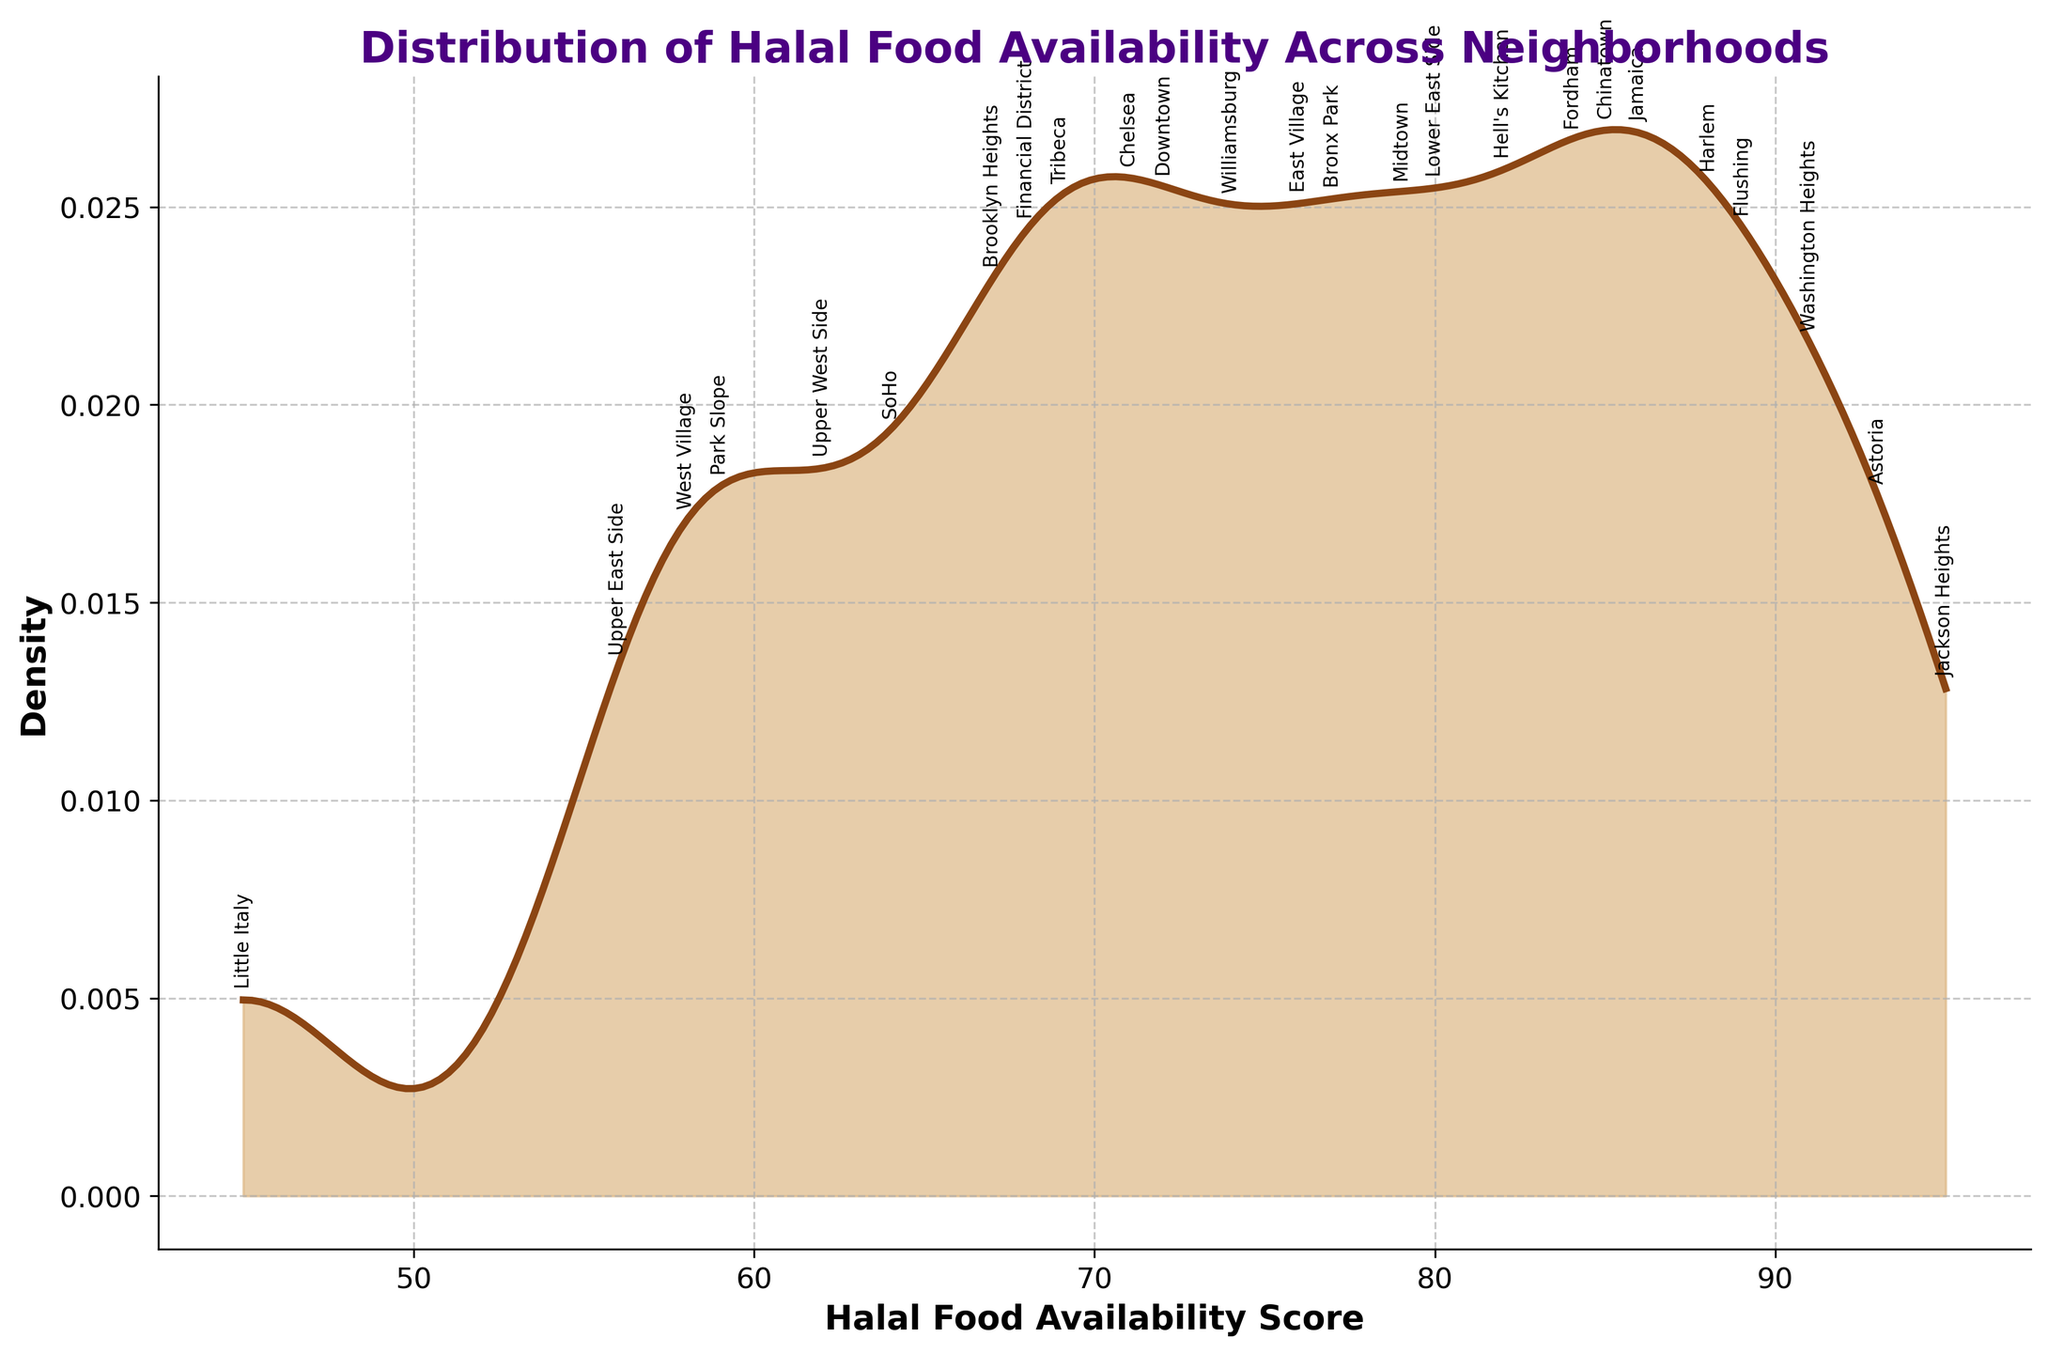What's the title of the figure? The title of the figure is usually found at the top. In this case, it clearly reads "Distribution of Halal Food Availability Across Neighborhoods".
Answer: Distribution of Halal Food Availability Across Neighborhoods What do the x-axis and y-axis represent? The x-axis and y-axis labels indicate what each axis measures. Here, the x-axis is labeled "Halal Food Availability Score" and the y-axis is labeled "Density".
Answer: Halal Food Availability Score and Density Which neighborhood has the highest halal food availability score? The figure shows labeled points for each neighborhood's score along the density curve. The highest score is labeled "Jackson Heights", which is around 95.
Answer: Jackson Heights What are the colors used in the plot? The plot uses two colors: a brownish line for the density curve and a light brown for the area under the curve. These colors can be identified by visual inspection.
Answer: Brown and light brown Is there a neighborhood with a score above 90, and if so, which one? The figure has annotated points that show the scores for each neighborhood. The scores above 90 are annotated, and these neighborhoods are "Astoria" (93) and "Jackson Heights" (95).
Answer: Astoria and Jackson Heights What is the shape or pattern of the density curve? The density curve is smooth and follows a typical bell shape, which is characteristic of a Gaussian distribution or normal distribution. The curve peaks around the middle and tapers towards the ends.
Answer: Bell-shaped curve What's the approximate median Halal Food Availability Score? The median is the middle score when the data is ordered. By looking at the density plot, the highest density area is around the 70-80 range. Thus, the median score is approximately in this range.
Answer: Approximately 77 Which neighborhood has a lower score, Lower East Side or Park Slope? By inspecting the annotated points, the scores of "Lower East Side" and "Park Slope" can be seen. Lower East Side has a score of 80, while Park Slope has 59, indicating Park Slope has a lower score.
Answer: Park Slope How does the density of scores above 85 compare to the density of scores below 45? By examining the filled density plot, scores above 85 represent a small area under the curve compared to scores below 45, which shows almost no density. Hence, scores above 85 have higher density.
Answer: Higher density above 85 Which neighborhood is closest to the median score? Identifying the median score around 77 by looking at the area under the curve, the neighborhood closest to this score is "Bronx Park" with a score of 77.
Answer: Bronx Park 